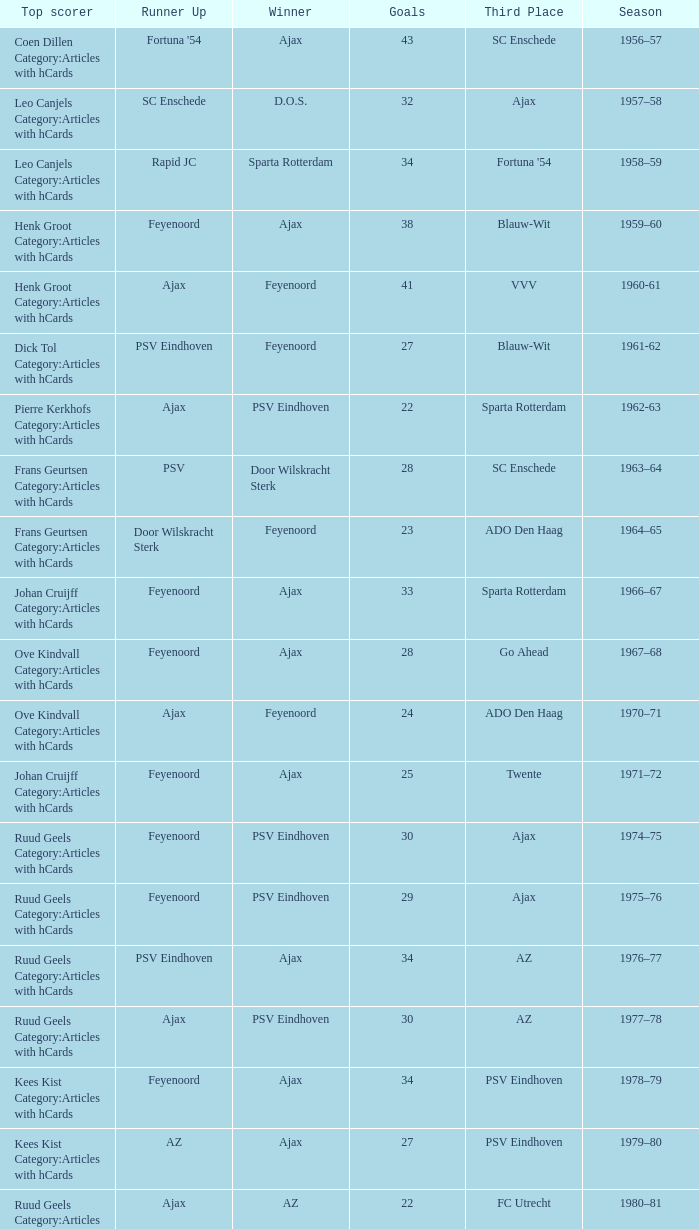When az is the runner up nad feyenoord came in third place how many overall winners are there? 1.0. 